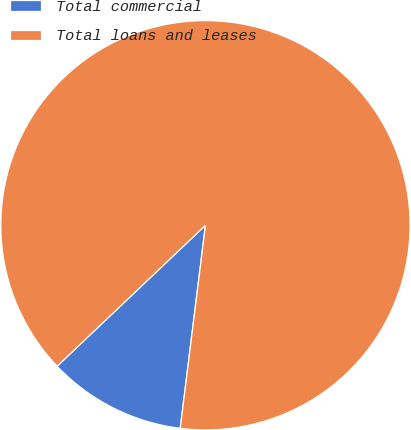<chart> <loc_0><loc_0><loc_500><loc_500><pie_chart><fcel>Total commercial<fcel>Total loans and leases<nl><fcel>10.94%<fcel>89.06%<nl></chart> 